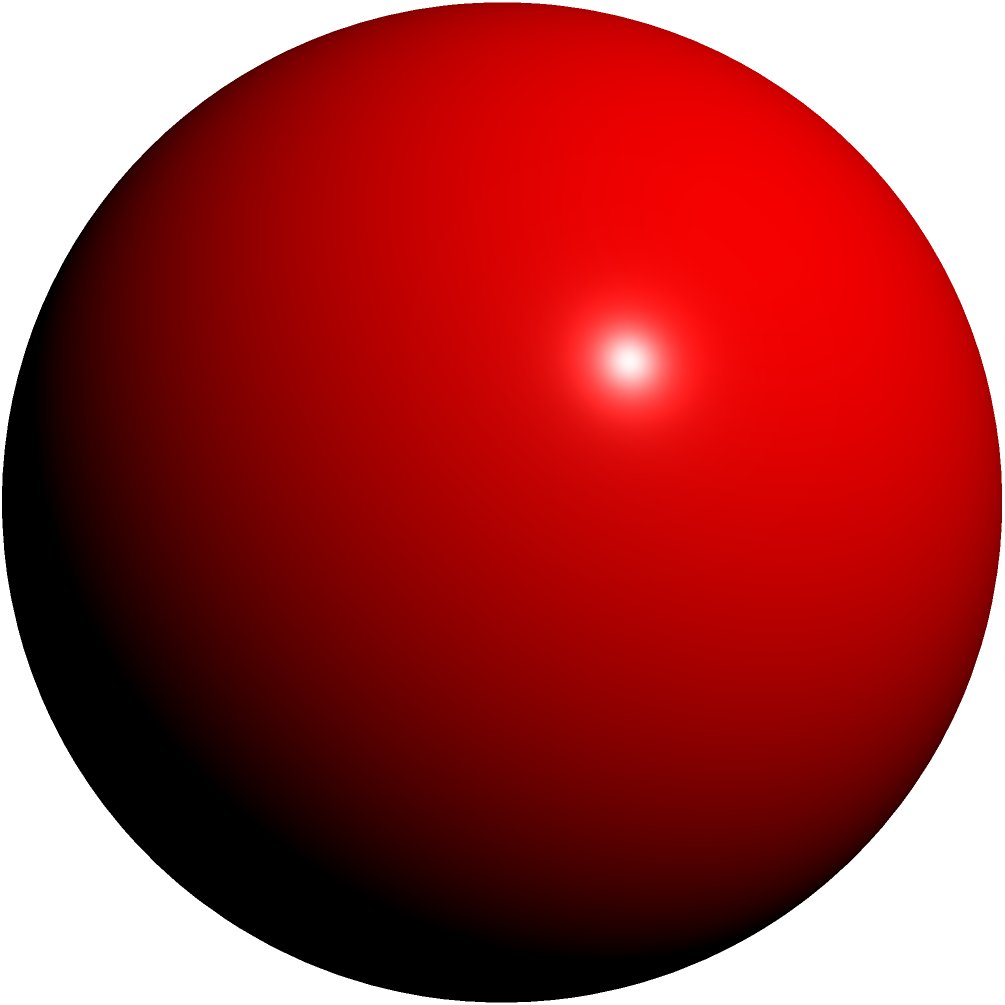In your latest novel, you've described a futuristic art installation featuring a transparent cube with a sphere suspended within it. The cube has an edge length of 10 meters, and the sphere perfectly touches all six faces of the cube. Calculate the surface area of the sphere, rounding your answer to the nearest whole number. How might this geometric precision reflect the themes of perfection and containment in your story? Let's approach this step-by-step:

1) In a cube with a perfectly inscribed sphere, the diameter of the sphere is equal to the length of the cube's edge. Here, the edge length is 10 meters.

2) Therefore, the diameter of the sphere is 10 meters, and its radius is 5 meters.

3) The formula for the surface area of a sphere is:
   
   $$A = 4\pi r^2$$

   where $A$ is the surface area and $r$ is the radius.

4) Substituting our radius of 5 meters:

   $$A = 4\pi (5^2) = 4\pi (25) = 100\pi$$

5) Calculate this value:
   
   $$100\pi \approx 314.159$$

6) Rounding to the nearest whole number:
   
   $$314.159 \approx 314$$

This geometric precision could symbolize the perfect balance or harmony in your story's world, while the sphere's containment within the cube might represent limitations or boundaries imposed on seemingly perfect systems or ideals.
Answer: 314 square meters 